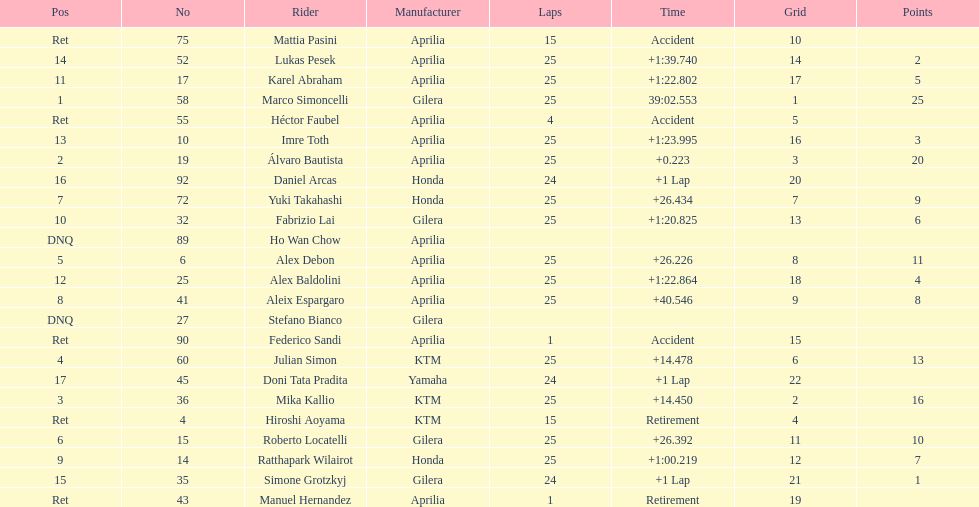The country with the most riders was Italy. 